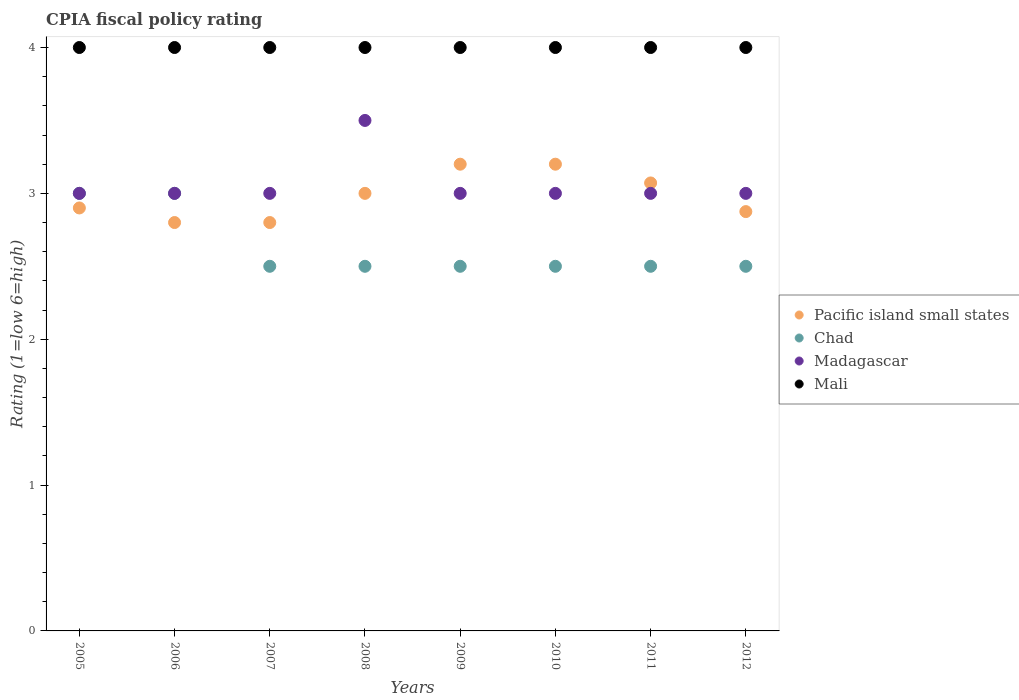Is the number of dotlines equal to the number of legend labels?
Ensure brevity in your answer.  Yes. What is the CPIA rating in Chad in 2006?
Provide a short and direct response. 3. In which year was the CPIA rating in Madagascar minimum?
Make the answer very short. 2005. What is the total CPIA rating in Madagascar in the graph?
Offer a very short reply. 24.5. What is the difference between the CPIA rating in Pacific island small states in 2008 and that in 2012?
Your response must be concise. 0.12. What is the difference between the CPIA rating in Chad in 2005 and the CPIA rating in Madagascar in 2008?
Your response must be concise. -0.5. What is the average CPIA rating in Madagascar per year?
Provide a short and direct response. 3.06. In the year 2009, what is the difference between the CPIA rating in Madagascar and CPIA rating in Chad?
Your answer should be very brief. 0.5. In how many years, is the CPIA rating in Mali greater than 1.6?
Make the answer very short. 8. What is the ratio of the CPIA rating in Pacific island small states in 2009 to that in 2011?
Your answer should be very brief. 1.04. Is the CPIA rating in Mali in 2005 less than that in 2007?
Give a very brief answer. No. What is the difference between the highest and the second highest CPIA rating in Pacific island small states?
Offer a very short reply. 0. Is the sum of the CPIA rating in Pacific island small states in 2010 and 2011 greater than the maximum CPIA rating in Madagascar across all years?
Offer a terse response. Yes. Is it the case that in every year, the sum of the CPIA rating in Chad and CPIA rating in Pacific island small states  is greater than the CPIA rating in Madagascar?
Your answer should be very brief. Yes. Does the CPIA rating in Mali monotonically increase over the years?
Give a very brief answer. No. Is the CPIA rating in Pacific island small states strictly greater than the CPIA rating in Mali over the years?
Give a very brief answer. No. How many dotlines are there?
Make the answer very short. 4. Are the values on the major ticks of Y-axis written in scientific E-notation?
Your response must be concise. No. Does the graph contain any zero values?
Your response must be concise. No. Does the graph contain grids?
Ensure brevity in your answer.  No. What is the title of the graph?
Provide a succinct answer. CPIA fiscal policy rating. Does "Greece" appear as one of the legend labels in the graph?
Make the answer very short. No. What is the label or title of the Y-axis?
Ensure brevity in your answer.  Rating (1=low 6=high). What is the Rating (1=low 6=high) in Pacific island small states in 2005?
Your response must be concise. 2.9. What is the Rating (1=low 6=high) in Chad in 2005?
Provide a succinct answer. 3. What is the Rating (1=low 6=high) of Madagascar in 2005?
Give a very brief answer. 3. What is the Rating (1=low 6=high) of Mali in 2005?
Your answer should be compact. 4. What is the Rating (1=low 6=high) in Mali in 2006?
Your answer should be very brief. 4. What is the Rating (1=low 6=high) in Madagascar in 2007?
Your answer should be compact. 3. What is the Rating (1=low 6=high) in Mali in 2007?
Offer a terse response. 4. What is the Rating (1=low 6=high) of Chad in 2008?
Ensure brevity in your answer.  2.5. What is the Rating (1=low 6=high) of Madagascar in 2008?
Provide a succinct answer. 3.5. What is the Rating (1=low 6=high) in Mali in 2008?
Keep it short and to the point. 4. What is the Rating (1=low 6=high) in Madagascar in 2009?
Give a very brief answer. 3. What is the Rating (1=low 6=high) in Mali in 2009?
Provide a succinct answer. 4. What is the Rating (1=low 6=high) of Pacific island small states in 2010?
Give a very brief answer. 3.2. What is the Rating (1=low 6=high) of Madagascar in 2010?
Offer a very short reply. 3. What is the Rating (1=low 6=high) of Mali in 2010?
Your answer should be compact. 4. What is the Rating (1=low 6=high) of Pacific island small states in 2011?
Keep it short and to the point. 3.07. What is the Rating (1=low 6=high) in Chad in 2011?
Your answer should be very brief. 2.5. What is the Rating (1=low 6=high) of Pacific island small states in 2012?
Provide a short and direct response. 2.88. What is the Rating (1=low 6=high) of Chad in 2012?
Ensure brevity in your answer.  2.5. What is the Rating (1=low 6=high) in Mali in 2012?
Give a very brief answer. 4. Across all years, what is the maximum Rating (1=low 6=high) in Pacific island small states?
Provide a short and direct response. 3.2. Across all years, what is the maximum Rating (1=low 6=high) in Chad?
Provide a succinct answer. 3. Across all years, what is the maximum Rating (1=low 6=high) of Madagascar?
Offer a terse response. 3.5. Across all years, what is the minimum Rating (1=low 6=high) in Chad?
Provide a succinct answer. 2.5. What is the total Rating (1=low 6=high) in Pacific island small states in the graph?
Ensure brevity in your answer.  23.85. What is the total Rating (1=low 6=high) in Madagascar in the graph?
Provide a short and direct response. 24.5. What is the difference between the Rating (1=low 6=high) of Chad in 2005 and that in 2006?
Ensure brevity in your answer.  0. What is the difference between the Rating (1=low 6=high) of Pacific island small states in 2005 and that in 2007?
Make the answer very short. 0.1. What is the difference between the Rating (1=low 6=high) in Pacific island small states in 2005 and that in 2008?
Ensure brevity in your answer.  -0.1. What is the difference between the Rating (1=low 6=high) in Madagascar in 2005 and that in 2008?
Provide a succinct answer. -0.5. What is the difference between the Rating (1=low 6=high) of Pacific island small states in 2005 and that in 2009?
Ensure brevity in your answer.  -0.3. What is the difference between the Rating (1=low 6=high) in Chad in 2005 and that in 2009?
Your answer should be compact. 0.5. What is the difference between the Rating (1=low 6=high) of Madagascar in 2005 and that in 2009?
Provide a short and direct response. 0. What is the difference between the Rating (1=low 6=high) of Mali in 2005 and that in 2009?
Provide a short and direct response. 0. What is the difference between the Rating (1=low 6=high) in Pacific island small states in 2005 and that in 2010?
Provide a succinct answer. -0.3. What is the difference between the Rating (1=low 6=high) in Madagascar in 2005 and that in 2010?
Ensure brevity in your answer.  0. What is the difference between the Rating (1=low 6=high) of Mali in 2005 and that in 2010?
Ensure brevity in your answer.  0. What is the difference between the Rating (1=low 6=high) in Pacific island small states in 2005 and that in 2011?
Give a very brief answer. -0.17. What is the difference between the Rating (1=low 6=high) in Chad in 2005 and that in 2011?
Keep it short and to the point. 0.5. What is the difference between the Rating (1=low 6=high) of Madagascar in 2005 and that in 2011?
Ensure brevity in your answer.  0. What is the difference between the Rating (1=low 6=high) in Pacific island small states in 2005 and that in 2012?
Provide a succinct answer. 0.03. What is the difference between the Rating (1=low 6=high) in Chad in 2005 and that in 2012?
Offer a terse response. 0.5. What is the difference between the Rating (1=low 6=high) in Madagascar in 2005 and that in 2012?
Give a very brief answer. 0. What is the difference between the Rating (1=low 6=high) in Chad in 2006 and that in 2007?
Provide a short and direct response. 0.5. What is the difference between the Rating (1=low 6=high) in Pacific island small states in 2006 and that in 2008?
Ensure brevity in your answer.  -0.2. What is the difference between the Rating (1=low 6=high) of Madagascar in 2006 and that in 2008?
Provide a succinct answer. -0.5. What is the difference between the Rating (1=low 6=high) in Pacific island small states in 2006 and that in 2009?
Provide a succinct answer. -0.4. What is the difference between the Rating (1=low 6=high) of Chad in 2006 and that in 2009?
Offer a terse response. 0.5. What is the difference between the Rating (1=low 6=high) in Madagascar in 2006 and that in 2009?
Provide a succinct answer. 0. What is the difference between the Rating (1=low 6=high) in Mali in 2006 and that in 2009?
Your answer should be very brief. 0. What is the difference between the Rating (1=low 6=high) in Madagascar in 2006 and that in 2010?
Give a very brief answer. 0. What is the difference between the Rating (1=low 6=high) of Pacific island small states in 2006 and that in 2011?
Your answer should be very brief. -0.27. What is the difference between the Rating (1=low 6=high) in Chad in 2006 and that in 2011?
Offer a terse response. 0.5. What is the difference between the Rating (1=low 6=high) of Madagascar in 2006 and that in 2011?
Keep it short and to the point. 0. What is the difference between the Rating (1=low 6=high) of Pacific island small states in 2006 and that in 2012?
Your answer should be compact. -0.07. What is the difference between the Rating (1=low 6=high) in Mali in 2006 and that in 2012?
Provide a succinct answer. 0. What is the difference between the Rating (1=low 6=high) in Pacific island small states in 2007 and that in 2008?
Your response must be concise. -0.2. What is the difference between the Rating (1=low 6=high) in Chad in 2007 and that in 2008?
Your answer should be compact. 0. What is the difference between the Rating (1=low 6=high) of Madagascar in 2007 and that in 2008?
Offer a very short reply. -0.5. What is the difference between the Rating (1=low 6=high) in Pacific island small states in 2007 and that in 2010?
Provide a short and direct response. -0.4. What is the difference between the Rating (1=low 6=high) in Chad in 2007 and that in 2010?
Keep it short and to the point. 0. What is the difference between the Rating (1=low 6=high) in Pacific island small states in 2007 and that in 2011?
Offer a very short reply. -0.27. What is the difference between the Rating (1=low 6=high) of Chad in 2007 and that in 2011?
Provide a succinct answer. 0. What is the difference between the Rating (1=low 6=high) of Pacific island small states in 2007 and that in 2012?
Your response must be concise. -0.07. What is the difference between the Rating (1=low 6=high) in Chad in 2007 and that in 2012?
Your answer should be compact. 0. What is the difference between the Rating (1=low 6=high) in Madagascar in 2007 and that in 2012?
Offer a terse response. 0. What is the difference between the Rating (1=low 6=high) in Chad in 2008 and that in 2009?
Your response must be concise. 0. What is the difference between the Rating (1=low 6=high) in Madagascar in 2008 and that in 2009?
Offer a terse response. 0.5. What is the difference between the Rating (1=low 6=high) in Pacific island small states in 2008 and that in 2010?
Keep it short and to the point. -0.2. What is the difference between the Rating (1=low 6=high) in Madagascar in 2008 and that in 2010?
Your answer should be very brief. 0.5. What is the difference between the Rating (1=low 6=high) in Pacific island small states in 2008 and that in 2011?
Give a very brief answer. -0.07. What is the difference between the Rating (1=low 6=high) of Chad in 2008 and that in 2011?
Ensure brevity in your answer.  0. What is the difference between the Rating (1=low 6=high) in Madagascar in 2008 and that in 2011?
Your response must be concise. 0.5. What is the difference between the Rating (1=low 6=high) of Mali in 2008 and that in 2011?
Offer a very short reply. 0. What is the difference between the Rating (1=low 6=high) of Pacific island small states in 2008 and that in 2012?
Give a very brief answer. 0.12. What is the difference between the Rating (1=low 6=high) in Madagascar in 2008 and that in 2012?
Provide a succinct answer. 0.5. What is the difference between the Rating (1=low 6=high) of Pacific island small states in 2009 and that in 2010?
Keep it short and to the point. 0. What is the difference between the Rating (1=low 6=high) in Chad in 2009 and that in 2010?
Provide a succinct answer. 0. What is the difference between the Rating (1=low 6=high) in Pacific island small states in 2009 and that in 2011?
Provide a succinct answer. 0.13. What is the difference between the Rating (1=low 6=high) in Madagascar in 2009 and that in 2011?
Keep it short and to the point. 0. What is the difference between the Rating (1=low 6=high) in Mali in 2009 and that in 2011?
Make the answer very short. 0. What is the difference between the Rating (1=low 6=high) of Pacific island small states in 2009 and that in 2012?
Offer a very short reply. 0.33. What is the difference between the Rating (1=low 6=high) in Pacific island small states in 2010 and that in 2011?
Offer a very short reply. 0.13. What is the difference between the Rating (1=low 6=high) in Madagascar in 2010 and that in 2011?
Offer a terse response. 0. What is the difference between the Rating (1=low 6=high) in Mali in 2010 and that in 2011?
Ensure brevity in your answer.  0. What is the difference between the Rating (1=low 6=high) in Pacific island small states in 2010 and that in 2012?
Give a very brief answer. 0.33. What is the difference between the Rating (1=low 6=high) in Pacific island small states in 2011 and that in 2012?
Offer a very short reply. 0.2. What is the difference between the Rating (1=low 6=high) of Chad in 2011 and that in 2012?
Offer a terse response. 0. What is the difference between the Rating (1=low 6=high) in Madagascar in 2011 and that in 2012?
Provide a short and direct response. 0. What is the difference between the Rating (1=low 6=high) in Mali in 2011 and that in 2012?
Your answer should be very brief. 0. What is the difference between the Rating (1=low 6=high) of Pacific island small states in 2005 and the Rating (1=low 6=high) of Madagascar in 2006?
Provide a succinct answer. -0.1. What is the difference between the Rating (1=low 6=high) in Chad in 2005 and the Rating (1=low 6=high) in Madagascar in 2006?
Ensure brevity in your answer.  0. What is the difference between the Rating (1=low 6=high) in Chad in 2005 and the Rating (1=low 6=high) in Mali in 2006?
Your answer should be compact. -1. What is the difference between the Rating (1=low 6=high) of Pacific island small states in 2005 and the Rating (1=low 6=high) of Madagascar in 2007?
Your response must be concise. -0.1. What is the difference between the Rating (1=low 6=high) of Pacific island small states in 2005 and the Rating (1=low 6=high) of Madagascar in 2008?
Give a very brief answer. -0.6. What is the difference between the Rating (1=low 6=high) of Pacific island small states in 2005 and the Rating (1=low 6=high) of Mali in 2008?
Your answer should be compact. -1.1. What is the difference between the Rating (1=low 6=high) of Chad in 2005 and the Rating (1=low 6=high) of Madagascar in 2008?
Offer a terse response. -0.5. What is the difference between the Rating (1=low 6=high) in Chad in 2005 and the Rating (1=low 6=high) in Mali in 2008?
Keep it short and to the point. -1. What is the difference between the Rating (1=low 6=high) in Pacific island small states in 2005 and the Rating (1=low 6=high) in Madagascar in 2009?
Your answer should be very brief. -0.1. What is the difference between the Rating (1=low 6=high) of Pacific island small states in 2005 and the Rating (1=low 6=high) of Mali in 2009?
Offer a terse response. -1.1. What is the difference between the Rating (1=low 6=high) of Pacific island small states in 2005 and the Rating (1=low 6=high) of Chad in 2010?
Make the answer very short. 0.4. What is the difference between the Rating (1=low 6=high) of Chad in 2005 and the Rating (1=low 6=high) of Madagascar in 2010?
Ensure brevity in your answer.  0. What is the difference between the Rating (1=low 6=high) in Chad in 2005 and the Rating (1=low 6=high) in Madagascar in 2011?
Give a very brief answer. 0. What is the difference between the Rating (1=low 6=high) in Chad in 2005 and the Rating (1=low 6=high) in Mali in 2011?
Keep it short and to the point. -1. What is the difference between the Rating (1=low 6=high) of Madagascar in 2005 and the Rating (1=low 6=high) of Mali in 2011?
Offer a very short reply. -1. What is the difference between the Rating (1=low 6=high) of Pacific island small states in 2005 and the Rating (1=low 6=high) of Madagascar in 2012?
Provide a short and direct response. -0.1. What is the difference between the Rating (1=low 6=high) in Pacific island small states in 2005 and the Rating (1=low 6=high) in Mali in 2012?
Keep it short and to the point. -1.1. What is the difference between the Rating (1=low 6=high) in Chad in 2005 and the Rating (1=low 6=high) in Mali in 2012?
Offer a very short reply. -1. What is the difference between the Rating (1=low 6=high) in Pacific island small states in 2006 and the Rating (1=low 6=high) in Chad in 2007?
Your response must be concise. 0.3. What is the difference between the Rating (1=low 6=high) in Pacific island small states in 2006 and the Rating (1=low 6=high) in Madagascar in 2007?
Provide a succinct answer. -0.2. What is the difference between the Rating (1=low 6=high) of Pacific island small states in 2006 and the Rating (1=low 6=high) of Mali in 2007?
Offer a very short reply. -1.2. What is the difference between the Rating (1=low 6=high) of Chad in 2006 and the Rating (1=low 6=high) of Madagascar in 2007?
Offer a terse response. 0. What is the difference between the Rating (1=low 6=high) of Chad in 2006 and the Rating (1=low 6=high) of Mali in 2007?
Make the answer very short. -1. What is the difference between the Rating (1=low 6=high) in Pacific island small states in 2006 and the Rating (1=low 6=high) in Madagascar in 2008?
Your response must be concise. -0.7. What is the difference between the Rating (1=low 6=high) of Chad in 2006 and the Rating (1=low 6=high) of Madagascar in 2008?
Offer a very short reply. -0.5. What is the difference between the Rating (1=low 6=high) in Madagascar in 2006 and the Rating (1=low 6=high) in Mali in 2008?
Ensure brevity in your answer.  -1. What is the difference between the Rating (1=low 6=high) of Pacific island small states in 2006 and the Rating (1=low 6=high) of Chad in 2009?
Provide a short and direct response. 0.3. What is the difference between the Rating (1=low 6=high) in Pacific island small states in 2006 and the Rating (1=low 6=high) in Mali in 2009?
Ensure brevity in your answer.  -1.2. What is the difference between the Rating (1=low 6=high) of Chad in 2006 and the Rating (1=low 6=high) of Madagascar in 2009?
Provide a short and direct response. 0. What is the difference between the Rating (1=low 6=high) in Pacific island small states in 2006 and the Rating (1=low 6=high) in Chad in 2010?
Offer a terse response. 0.3. What is the difference between the Rating (1=low 6=high) in Chad in 2006 and the Rating (1=low 6=high) in Madagascar in 2010?
Ensure brevity in your answer.  0. What is the difference between the Rating (1=low 6=high) in Chad in 2006 and the Rating (1=low 6=high) in Mali in 2010?
Provide a succinct answer. -1. What is the difference between the Rating (1=low 6=high) in Madagascar in 2006 and the Rating (1=low 6=high) in Mali in 2010?
Offer a very short reply. -1. What is the difference between the Rating (1=low 6=high) in Pacific island small states in 2006 and the Rating (1=low 6=high) in Madagascar in 2011?
Provide a short and direct response. -0.2. What is the difference between the Rating (1=low 6=high) in Chad in 2006 and the Rating (1=low 6=high) in Madagascar in 2011?
Make the answer very short. 0. What is the difference between the Rating (1=low 6=high) in Chad in 2006 and the Rating (1=low 6=high) in Mali in 2011?
Your response must be concise. -1. What is the difference between the Rating (1=low 6=high) of Madagascar in 2006 and the Rating (1=low 6=high) of Mali in 2011?
Offer a very short reply. -1. What is the difference between the Rating (1=low 6=high) in Chad in 2006 and the Rating (1=low 6=high) in Mali in 2012?
Your response must be concise. -1. What is the difference between the Rating (1=low 6=high) in Madagascar in 2006 and the Rating (1=low 6=high) in Mali in 2012?
Offer a very short reply. -1. What is the difference between the Rating (1=low 6=high) in Pacific island small states in 2007 and the Rating (1=low 6=high) in Mali in 2008?
Ensure brevity in your answer.  -1.2. What is the difference between the Rating (1=low 6=high) in Chad in 2007 and the Rating (1=low 6=high) in Madagascar in 2008?
Offer a terse response. -1. What is the difference between the Rating (1=low 6=high) in Madagascar in 2007 and the Rating (1=low 6=high) in Mali in 2008?
Make the answer very short. -1. What is the difference between the Rating (1=low 6=high) of Madagascar in 2007 and the Rating (1=low 6=high) of Mali in 2009?
Your response must be concise. -1. What is the difference between the Rating (1=low 6=high) of Pacific island small states in 2007 and the Rating (1=low 6=high) of Chad in 2010?
Provide a succinct answer. 0.3. What is the difference between the Rating (1=low 6=high) of Pacific island small states in 2007 and the Rating (1=low 6=high) of Mali in 2010?
Your answer should be compact. -1.2. What is the difference between the Rating (1=low 6=high) of Madagascar in 2007 and the Rating (1=low 6=high) of Mali in 2010?
Your response must be concise. -1. What is the difference between the Rating (1=low 6=high) of Pacific island small states in 2007 and the Rating (1=low 6=high) of Mali in 2011?
Provide a short and direct response. -1.2. What is the difference between the Rating (1=low 6=high) in Pacific island small states in 2007 and the Rating (1=low 6=high) in Chad in 2012?
Offer a terse response. 0.3. What is the difference between the Rating (1=low 6=high) in Pacific island small states in 2007 and the Rating (1=low 6=high) in Madagascar in 2012?
Your answer should be very brief. -0.2. What is the difference between the Rating (1=low 6=high) in Chad in 2007 and the Rating (1=low 6=high) in Madagascar in 2012?
Your response must be concise. -0.5. What is the difference between the Rating (1=low 6=high) in Madagascar in 2007 and the Rating (1=low 6=high) in Mali in 2012?
Your answer should be very brief. -1. What is the difference between the Rating (1=low 6=high) in Pacific island small states in 2008 and the Rating (1=low 6=high) in Chad in 2009?
Offer a terse response. 0.5. What is the difference between the Rating (1=low 6=high) in Chad in 2008 and the Rating (1=low 6=high) in Madagascar in 2009?
Offer a terse response. -0.5. What is the difference between the Rating (1=low 6=high) in Madagascar in 2008 and the Rating (1=low 6=high) in Mali in 2009?
Make the answer very short. -0.5. What is the difference between the Rating (1=low 6=high) in Pacific island small states in 2008 and the Rating (1=low 6=high) in Mali in 2010?
Keep it short and to the point. -1. What is the difference between the Rating (1=low 6=high) of Chad in 2008 and the Rating (1=low 6=high) of Madagascar in 2010?
Ensure brevity in your answer.  -0.5. What is the difference between the Rating (1=low 6=high) in Madagascar in 2008 and the Rating (1=low 6=high) in Mali in 2010?
Give a very brief answer. -0.5. What is the difference between the Rating (1=low 6=high) of Chad in 2008 and the Rating (1=low 6=high) of Madagascar in 2011?
Ensure brevity in your answer.  -0.5. What is the difference between the Rating (1=low 6=high) of Madagascar in 2008 and the Rating (1=low 6=high) of Mali in 2011?
Offer a terse response. -0.5. What is the difference between the Rating (1=low 6=high) of Pacific island small states in 2008 and the Rating (1=low 6=high) of Chad in 2012?
Provide a short and direct response. 0.5. What is the difference between the Rating (1=low 6=high) in Pacific island small states in 2008 and the Rating (1=low 6=high) in Mali in 2012?
Provide a short and direct response. -1. What is the difference between the Rating (1=low 6=high) of Chad in 2008 and the Rating (1=low 6=high) of Madagascar in 2012?
Your answer should be compact. -0.5. What is the difference between the Rating (1=low 6=high) in Madagascar in 2008 and the Rating (1=low 6=high) in Mali in 2012?
Provide a short and direct response. -0.5. What is the difference between the Rating (1=low 6=high) in Pacific island small states in 2009 and the Rating (1=low 6=high) in Chad in 2010?
Ensure brevity in your answer.  0.7. What is the difference between the Rating (1=low 6=high) of Pacific island small states in 2009 and the Rating (1=low 6=high) of Madagascar in 2010?
Give a very brief answer. 0.2. What is the difference between the Rating (1=low 6=high) in Pacific island small states in 2009 and the Rating (1=low 6=high) in Mali in 2010?
Your response must be concise. -0.8. What is the difference between the Rating (1=low 6=high) in Pacific island small states in 2009 and the Rating (1=low 6=high) in Chad in 2011?
Offer a terse response. 0.7. What is the difference between the Rating (1=low 6=high) in Pacific island small states in 2009 and the Rating (1=low 6=high) in Madagascar in 2011?
Offer a very short reply. 0.2. What is the difference between the Rating (1=low 6=high) of Chad in 2009 and the Rating (1=low 6=high) of Madagascar in 2011?
Keep it short and to the point. -0.5. What is the difference between the Rating (1=low 6=high) of Chad in 2009 and the Rating (1=low 6=high) of Mali in 2011?
Provide a succinct answer. -1.5. What is the difference between the Rating (1=low 6=high) of Pacific island small states in 2009 and the Rating (1=low 6=high) of Chad in 2012?
Offer a terse response. 0.7. What is the difference between the Rating (1=low 6=high) in Pacific island small states in 2009 and the Rating (1=low 6=high) in Mali in 2012?
Provide a succinct answer. -0.8. What is the difference between the Rating (1=low 6=high) of Chad in 2009 and the Rating (1=low 6=high) of Madagascar in 2012?
Provide a succinct answer. -0.5. What is the difference between the Rating (1=low 6=high) of Chad in 2009 and the Rating (1=low 6=high) of Mali in 2012?
Ensure brevity in your answer.  -1.5. What is the difference between the Rating (1=low 6=high) of Madagascar in 2009 and the Rating (1=low 6=high) of Mali in 2012?
Offer a terse response. -1. What is the difference between the Rating (1=low 6=high) of Madagascar in 2010 and the Rating (1=low 6=high) of Mali in 2011?
Provide a short and direct response. -1. What is the difference between the Rating (1=low 6=high) in Pacific island small states in 2010 and the Rating (1=low 6=high) in Chad in 2012?
Make the answer very short. 0.7. What is the difference between the Rating (1=low 6=high) of Pacific island small states in 2011 and the Rating (1=low 6=high) of Chad in 2012?
Ensure brevity in your answer.  0.57. What is the difference between the Rating (1=low 6=high) of Pacific island small states in 2011 and the Rating (1=low 6=high) of Madagascar in 2012?
Provide a succinct answer. 0.07. What is the difference between the Rating (1=low 6=high) of Pacific island small states in 2011 and the Rating (1=low 6=high) of Mali in 2012?
Keep it short and to the point. -0.93. What is the difference between the Rating (1=low 6=high) of Chad in 2011 and the Rating (1=low 6=high) of Madagascar in 2012?
Your answer should be very brief. -0.5. What is the difference between the Rating (1=low 6=high) of Chad in 2011 and the Rating (1=low 6=high) of Mali in 2012?
Ensure brevity in your answer.  -1.5. What is the difference between the Rating (1=low 6=high) of Madagascar in 2011 and the Rating (1=low 6=high) of Mali in 2012?
Your answer should be very brief. -1. What is the average Rating (1=low 6=high) in Pacific island small states per year?
Offer a terse response. 2.98. What is the average Rating (1=low 6=high) of Chad per year?
Your answer should be compact. 2.62. What is the average Rating (1=low 6=high) in Madagascar per year?
Offer a terse response. 3.06. What is the average Rating (1=low 6=high) in Mali per year?
Your answer should be compact. 4. In the year 2005, what is the difference between the Rating (1=low 6=high) of Pacific island small states and Rating (1=low 6=high) of Madagascar?
Offer a terse response. -0.1. In the year 2005, what is the difference between the Rating (1=low 6=high) of Pacific island small states and Rating (1=low 6=high) of Mali?
Make the answer very short. -1.1. In the year 2005, what is the difference between the Rating (1=low 6=high) in Chad and Rating (1=low 6=high) in Mali?
Give a very brief answer. -1. In the year 2006, what is the difference between the Rating (1=low 6=high) of Madagascar and Rating (1=low 6=high) of Mali?
Ensure brevity in your answer.  -1. In the year 2007, what is the difference between the Rating (1=low 6=high) in Chad and Rating (1=low 6=high) in Madagascar?
Provide a succinct answer. -0.5. In the year 2007, what is the difference between the Rating (1=low 6=high) in Madagascar and Rating (1=low 6=high) in Mali?
Give a very brief answer. -1. In the year 2008, what is the difference between the Rating (1=low 6=high) of Pacific island small states and Rating (1=low 6=high) of Chad?
Offer a terse response. 0.5. In the year 2008, what is the difference between the Rating (1=low 6=high) of Pacific island small states and Rating (1=low 6=high) of Madagascar?
Your response must be concise. -0.5. In the year 2008, what is the difference between the Rating (1=low 6=high) in Pacific island small states and Rating (1=low 6=high) in Mali?
Your response must be concise. -1. In the year 2008, what is the difference between the Rating (1=low 6=high) of Chad and Rating (1=low 6=high) of Madagascar?
Your answer should be very brief. -1. In the year 2008, what is the difference between the Rating (1=low 6=high) in Chad and Rating (1=low 6=high) in Mali?
Your response must be concise. -1.5. In the year 2008, what is the difference between the Rating (1=low 6=high) in Madagascar and Rating (1=low 6=high) in Mali?
Make the answer very short. -0.5. In the year 2009, what is the difference between the Rating (1=low 6=high) of Pacific island small states and Rating (1=low 6=high) of Chad?
Make the answer very short. 0.7. In the year 2009, what is the difference between the Rating (1=low 6=high) of Pacific island small states and Rating (1=low 6=high) of Madagascar?
Your answer should be compact. 0.2. In the year 2009, what is the difference between the Rating (1=low 6=high) in Pacific island small states and Rating (1=low 6=high) in Mali?
Provide a short and direct response. -0.8. In the year 2009, what is the difference between the Rating (1=low 6=high) of Chad and Rating (1=low 6=high) of Madagascar?
Offer a very short reply. -0.5. In the year 2009, what is the difference between the Rating (1=low 6=high) in Madagascar and Rating (1=low 6=high) in Mali?
Make the answer very short. -1. In the year 2010, what is the difference between the Rating (1=low 6=high) in Chad and Rating (1=low 6=high) in Mali?
Make the answer very short. -1.5. In the year 2011, what is the difference between the Rating (1=low 6=high) in Pacific island small states and Rating (1=low 6=high) in Chad?
Your answer should be very brief. 0.57. In the year 2011, what is the difference between the Rating (1=low 6=high) in Pacific island small states and Rating (1=low 6=high) in Madagascar?
Provide a short and direct response. 0.07. In the year 2011, what is the difference between the Rating (1=low 6=high) in Pacific island small states and Rating (1=low 6=high) in Mali?
Your response must be concise. -0.93. In the year 2011, what is the difference between the Rating (1=low 6=high) in Chad and Rating (1=low 6=high) in Madagascar?
Give a very brief answer. -0.5. In the year 2011, what is the difference between the Rating (1=low 6=high) in Madagascar and Rating (1=low 6=high) in Mali?
Your answer should be very brief. -1. In the year 2012, what is the difference between the Rating (1=low 6=high) of Pacific island small states and Rating (1=low 6=high) of Madagascar?
Provide a short and direct response. -0.12. In the year 2012, what is the difference between the Rating (1=low 6=high) of Pacific island small states and Rating (1=low 6=high) of Mali?
Keep it short and to the point. -1.12. In the year 2012, what is the difference between the Rating (1=low 6=high) in Chad and Rating (1=low 6=high) in Madagascar?
Your answer should be very brief. -0.5. What is the ratio of the Rating (1=low 6=high) in Pacific island small states in 2005 to that in 2006?
Your response must be concise. 1.04. What is the ratio of the Rating (1=low 6=high) in Chad in 2005 to that in 2006?
Your response must be concise. 1. What is the ratio of the Rating (1=low 6=high) in Mali in 2005 to that in 2006?
Offer a terse response. 1. What is the ratio of the Rating (1=low 6=high) of Pacific island small states in 2005 to that in 2007?
Ensure brevity in your answer.  1.04. What is the ratio of the Rating (1=low 6=high) of Chad in 2005 to that in 2007?
Provide a succinct answer. 1.2. What is the ratio of the Rating (1=low 6=high) of Madagascar in 2005 to that in 2007?
Offer a terse response. 1. What is the ratio of the Rating (1=low 6=high) of Mali in 2005 to that in 2007?
Give a very brief answer. 1. What is the ratio of the Rating (1=low 6=high) of Pacific island small states in 2005 to that in 2008?
Make the answer very short. 0.97. What is the ratio of the Rating (1=low 6=high) in Mali in 2005 to that in 2008?
Your response must be concise. 1. What is the ratio of the Rating (1=low 6=high) of Pacific island small states in 2005 to that in 2009?
Give a very brief answer. 0.91. What is the ratio of the Rating (1=low 6=high) in Chad in 2005 to that in 2009?
Ensure brevity in your answer.  1.2. What is the ratio of the Rating (1=low 6=high) of Pacific island small states in 2005 to that in 2010?
Your response must be concise. 0.91. What is the ratio of the Rating (1=low 6=high) of Mali in 2005 to that in 2010?
Give a very brief answer. 1. What is the ratio of the Rating (1=low 6=high) in Pacific island small states in 2005 to that in 2011?
Your answer should be compact. 0.94. What is the ratio of the Rating (1=low 6=high) of Madagascar in 2005 to that in 2011?
Your answer should be very brief. 1. What is the ratio of the Rating (1=low 6=high) of Pacific island small states in 2005 to that in 2012?
Your response must be concise. 1.01. What is the ratio of the Rating (1=low 6=high) in Chad in 2005 to that in 2012?
Provide a short and direct response. 1.2. What is the ratio of the Rating (1=low 6=high) of Mali in 2006 to that in 2007?
Ensure brevity in your answer.  1. What is the ratio of the Rating (1=low 6=high) in Madagascar in 2006 to that in 2008?
Your answer should be very brief. 0.86. What is the ratio of the Rating (1=low 6=high) of Mali in 2006 to that in 2008?
Offer a very short reply. 1. What is the ratio of the Rating (1=low 6=high) in Pacific island small states in 2006 to that in 2009?
Provide a short and direct response. 0.88. What is the ratio of the Rating (1=low 6=high) of Madagascar in 2006 to that in 2009?
Make the answer very short. 1. What is the ratio of the Rating (1=low 6=high) in Madagascar in 2006 to that in 2010?
Offer a terse response. 1. What is the ratio of the Rating (1=low 6=high) in Mali in 2006 to that in 2010?
Provide a short and direct response. 1. What is the ratio of the Rating (1=low 6=high) in Pacific island small states in 2006 to that in 2011?
Provide a succinct answer. 0.91. What is the ratio of the Rating (1=low 6=high) in Chad in 2006 to that in 2011?
Make the answer very short. 1.2. What is the ratio of the Rating (1=low 6=high) of Madagascar in 2006 to that in 2011?
Offer a very short reply. 1. What is the ratio of the Rating (1=low 6=high) of Pacific island small states in 2006 to that in 2012?
Your answer should be compact. 0.97. What is the ratio of the Rating (1=low 6=high) in Chad in 2007 to that in 2008?
Make the answer very short. 1. What is the ratio of the Rating (1=low 6=high) in Madagascar in 2007 to that in 2008?
Your answer should be compact. 0.86. What is the ratio of the Rating (1=low 6=high) in Pacific island small states in 2007 to that in 2009?
Offer a terse response. 0.88. What is the ratio of the Rating (1=low 6=high) in Pacific island small states in 2007 to that in 2010?
Offer a terse response. 0.88. What is the ratio of the Rating (1=low 6=high) in Pacific island small states in 2007 to that in 2011?
Your answer should be compact. 0.91. What is the ratio of the Rating (1=low 6=high) of Chad in 2007 to that in 2011?
Make the answer very short. 1. What is the ratio of the Rating (1=low 6=high) of Madagascar in 2007 to that in 2011?
Your answer should be very brief. 1. What is the ratio of the Rating (1=low 6=high) of Pacific island small states in 2007 to that in 2012?
Keep it short and to the point. 0.97. What is the ratio of the Rating (1=low 6=high) of Chad in 2007 to that in 2012?
Ensure brevity in your answer.  1. What is the ratio of the Rating (1=low 6=high) of Madagascar in 2007 to that in 2012?
Offer a very short reply. 1. What is the ratio of the Rating (1=low 6=high) of Pacific island small states in 2008 to that in 2009?
Give a very brief answer. 0.94. What is the ratio of the Rating (1=low 6=high) of Chad in 2008 to that in 2009?
Provide a succinct answer. 1. What is the ratio of the Rating (1=low 6=high) in Madagascar in 2008 to that in 2009?
Provide a succinct answer. 1.17. What is the ratio of the Rating (1=low 6=high) of Pacific island small states in 2008 to that in 2010?
Keep it short and to the point. 0.94. What is the ratio of the Rating (1=low 6=high) in Chad in 2008 to that in 2010?
Your response must be concise. 1. What is the ratio of the Rating (1=low 6=high) in Pacific island small states in 2008 to that in 2011?
Ensure brevity in your answer.  0.98. What is the ratio of the Rating (1=low 6=high) of Chad in 2008 to that in 2011?
Provide a succinct answer. 1. What is the ratio of the Rating (1=low 6=high) in Madagascar in 2008 to that in 2011?
Offer a terse response. 1.17. What is the ratio of the Rating (1=low 6=high) of Pacific island small states in 2008 to that in 2012?
Make the answer very short. 1.04. What is the ratio of the Rating (1=low 6=high) of Madagascar in 2008 to that in 2012?
Provide a succinct answer. 1.17. What is the ratio of the Rating (1=low 6=high) in Pacific island small states in 2009 to that in 2010?
Ensure brevity in your answer.  1. What is the ratio of the Rating (1=low 6=high) in Chad in 2009 to that in 2010?
Ensure brevity in your answer.  1. What is the ratio of the Rating (1=low 6=high) in Pacific island small states in 2009 to that in 2011?
Your response must be concise. 1.04. What is the ratio of the Rating (1=low 6=high) in Chad in 2009 to that in 2011?
Keep it short and to the point. 1. What is the ratio of the Rating (1=low 6=high) in Pacific island small states in 2009 to that in 2012?
Ensure brevity in your answer.  1.11. What is the ratio of the Rating (1=low 6=high) of Mali in 2009 to that in 2012?
Make the answer very short. 1. What is the ratio of the Rating (1=low 6=high) in Pacific island small states in 2010 to that in 2011?
Make the answer very short. 1.04. What is the ratio of the Rating (1=low 6=high) of Madagascar in 2010 to that in 2011?
Make the answer very short. 1. What is the ratio of the Rating (1=low 6=high) in Pacific island small states in 2010 to that in 2012?
Provide a short and direct response. 1.11. What is the ratio of the Rating (1=low 6=high) in Madagascar in 2010 to that in 2012?
Offer a terse response. 1. What is the ratio of the Rating (1=low 6=high) in Pacific island small states in 2011 to that in 2012?
Your answer should be compact. 1.07. What is the ratio of the Rating (1=low 6=high) in Chad in 2011 to that in 2012?
Offer a terse response. 1. What is the ratio of the Rating (1=low 6=high) in Madagascar in 2011 to that in 2012?
Ensure brevity in your answer.  1. What is the ratio of the Rating (1=low 6=high) of Mali in 2011 to that in 2012?
Provide a short and direct response. 1. What is the difference between the highest and the second highest Rating (1=low 6=high) of Madagascar?
Ensure brevity in your answer.  0.5. What is the difference between the highest and the second highest Rating (1=low 6=high) of Mali?
Your response must be concise. 0. What is the difference between the highest and the lowest Rating (1=low 6=high) of Pacific island small states?
Your answer should be compact. 0.4. What is the difference between the highest and the lowest Rating (1=low 6=high) of Madagascar?
Ensure brevity in your answer.  0.5. What is the difference between the highest and the lowest Rating (1=low 6=high) of Mali?
Ensure brevity in your answer.  0. 